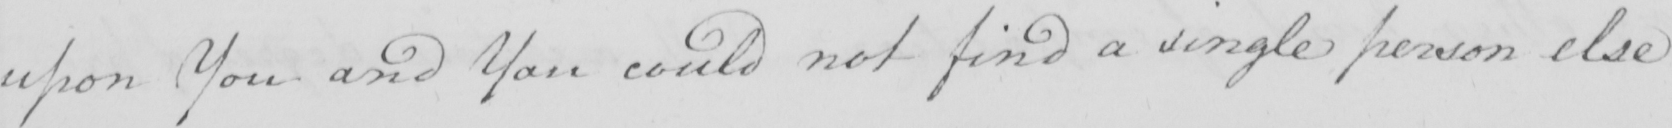Please provide the text content of this handwritten line. upon You and You could not find a single person else 